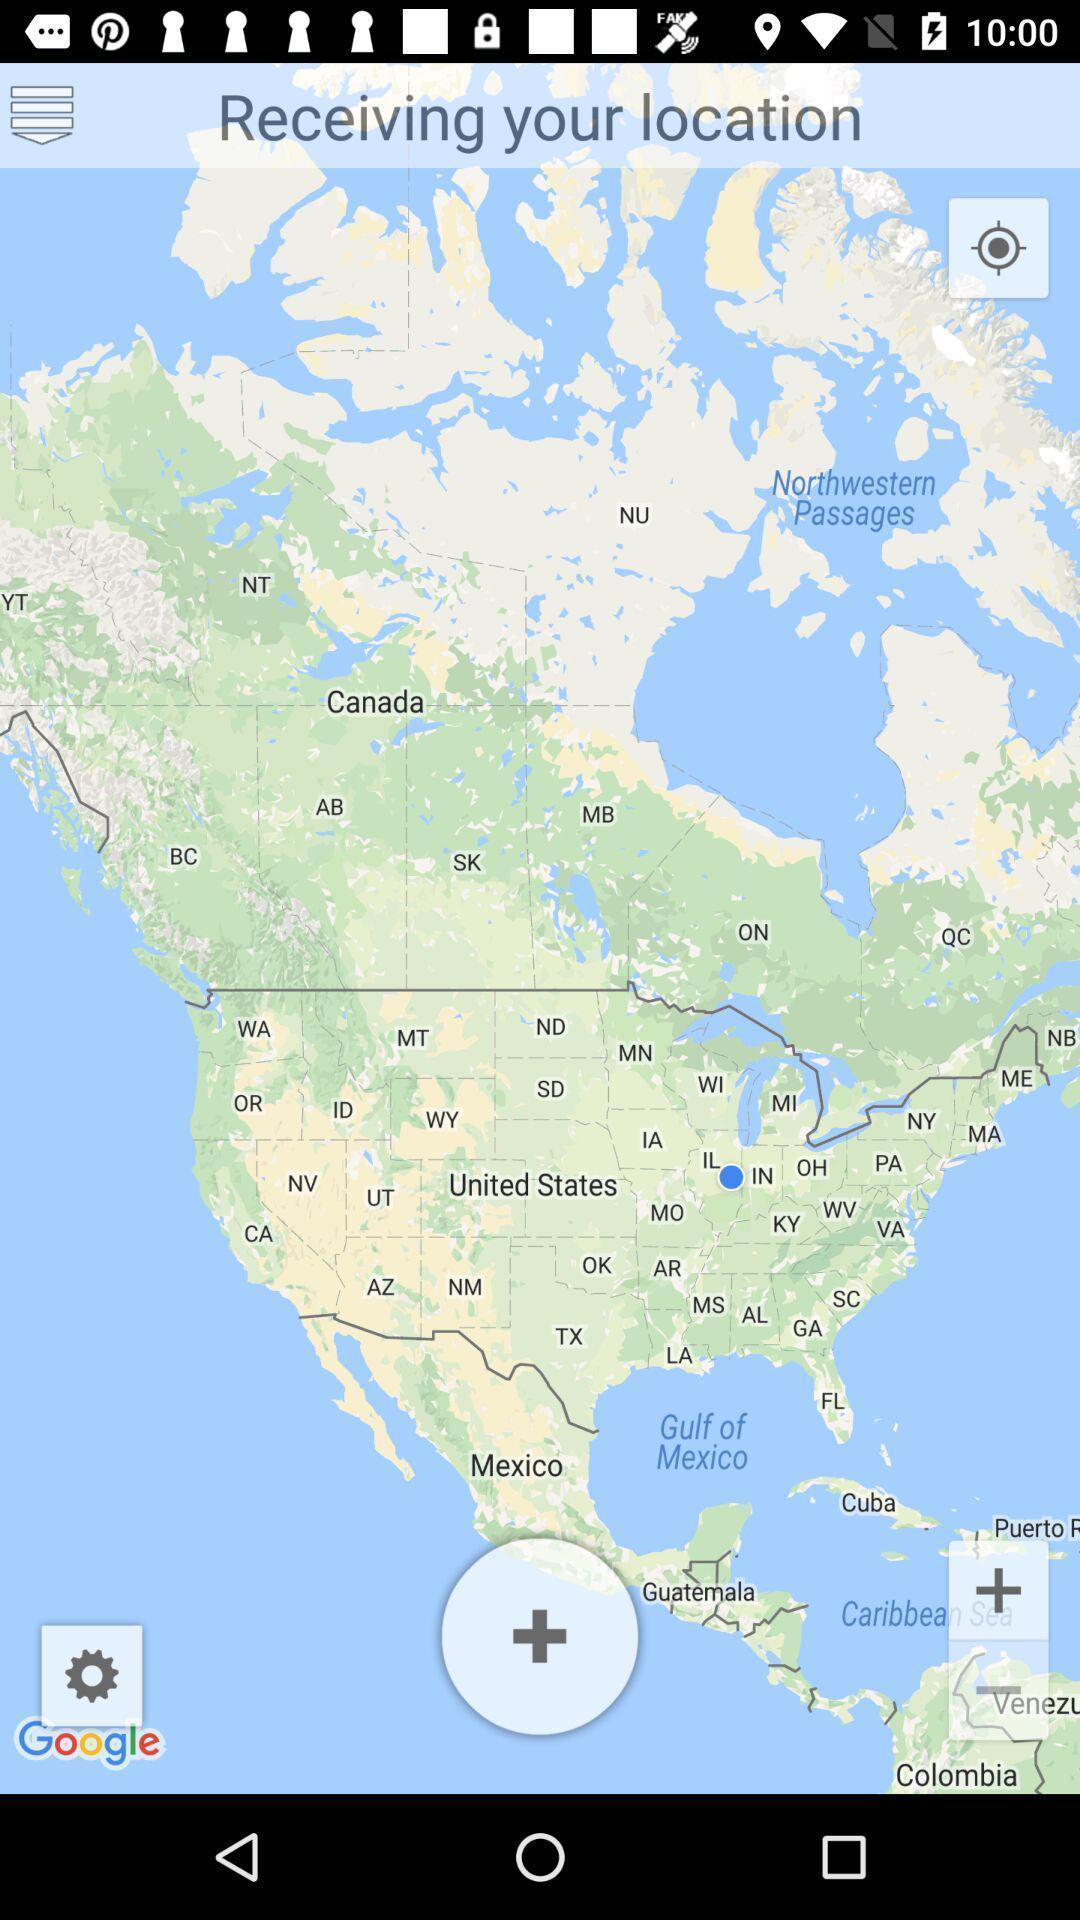Explain what's happening in this screen capture. Page showing the mapping page with multiple options. 